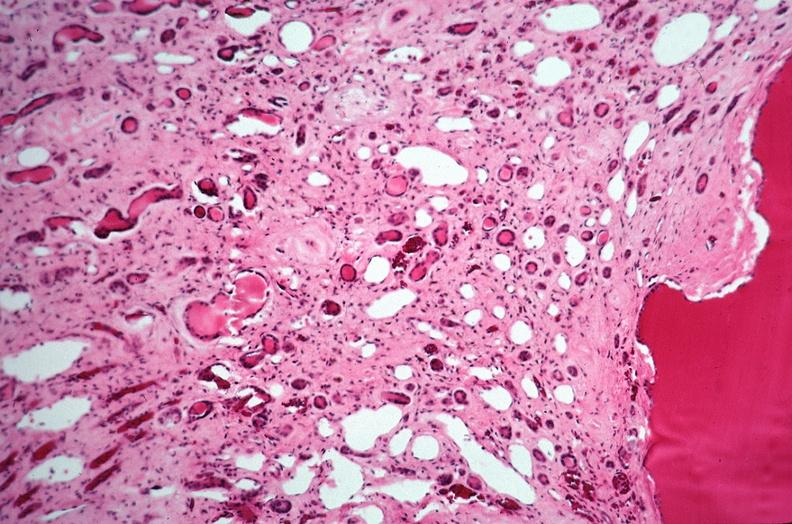does muscle show kidney, adult polycystic kidney?
Answer the question using a single word or phrase. No 